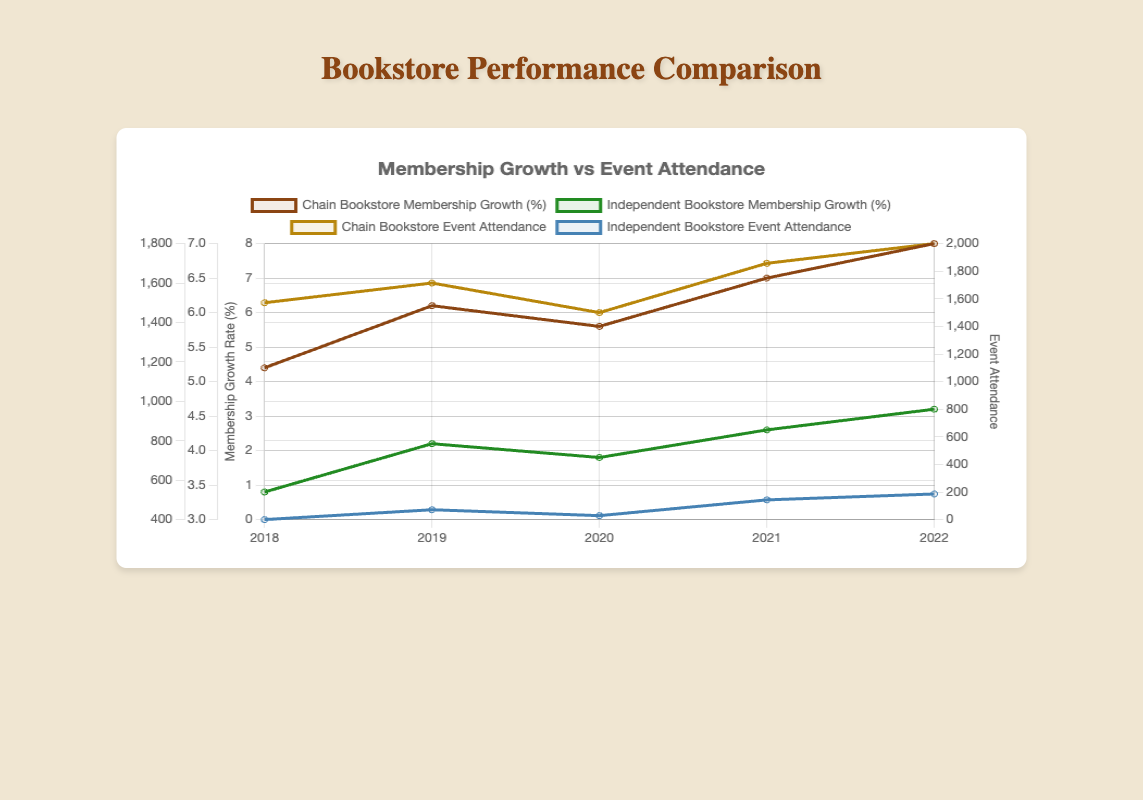what's the largest growth in membership for the chain bookstore? Look at the "Chain Bookstore Membership Growth (%)" curve and identify the year with the highest value, which is 7.0% in 2022.
Answer: 7.0% Which year shows the lowest event attendance for the chain bookstore? Review the "Chain Bookstore Event Attendance" curve and locate the lowest value, which is 1450 in 2020.
Answer: 2020 By how much did the chain bookstore's event attendance increase from 2020 to 2021? Find the "Chain Bookstore Event Attendance" value for 2020 (1450) and 2021 (1700). Subtract 1450 from 1700, which equals 250.
Answer: 250 What is the average membership growth rate for the independent bookstore over the given years? Sum the "Independent Bookstore Membership Growth (%)" values: 3.4 + 4.1 + 3.9 + 4.3 + 4.6 = 20.3. Divide by 5 (the number of years), which is 20.3/5 = 4.06.
Answer: 4.06% Which type of rate has a larger overall increasing trend for the chain bookstore: membership growth or event attendance? Compare the slopes of the "Chain Bookstore Membership Growth (%)" and "Chain Bookstore Event Attendance" curves. Membership growth rate increases from 5.2% to 7.0% while event attendance increases from 1500 to 1800. The membership growth rate shows a larger relative increase.
Answer: Membership growth In 2021, what is the difference in event attendance between the chain bookstore and the independent bookstore? Identify the event attendance values in 2021 for both bookstores: 1700 for the chain bookstore and 500 for the independent bookstore. Subtract 500 from 1700, which equals 1200.
Answer: 1200 What's the overall trend in membership growth rate for both bookstores from 2018 to 2022? Observe both curves: the chain bookstore's growth consistently rises from 5.2% to 7.0%. The independent bookstore's growth also rises from 3.4% to 4.6%. Both show an increasing trend.
Answer: Increasing What is the highest event attendance recorded for the independent bookstore? Examine the "Independent Bookstore Event Attendance" curve and find the highest value, which is 530 in 2022.
Answer: 530 Compare the membership growth rates of both bookstores in 2019. Which one is higher and by how much? Locate the values for 2019: the chain bookstore has 6.1% and the independent bookstore has 4.1%. Subtract 4.1% from 6.1%, which equals 2.
Answer: Chain bookstore, by 2.0% What's the difference in event attendance for the independent bookstore between 2018 and 2022? Find the event attendance values for 2018 (400) and 2022 (530). Subtract 400 from 530, which equals 130.
Answer: 130 